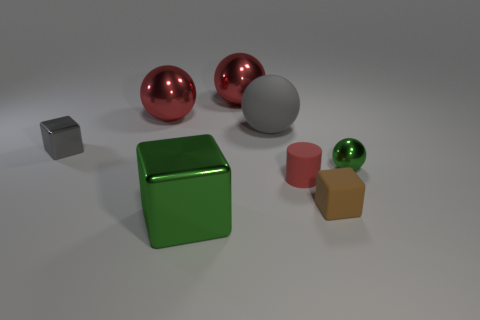Subtract all blocks. How many objects are left? 5 Subtract all matte spheres. How many spheres are left? 3 Add 2 small cyan metallic things. How many objects exist? 10 Subtract all green balls. How many balls are left? 3 Subtract 0 brown spheres. How many objects are left? 8 Subtract 2 cubes. How many cubes are left? 1 Subtract all green cylinders. Subtract all blue balls. How many cylinders are left? 1 Subtract all blue balls. How many red blocks are left? 0 Subtract all gray things. Subtract all blue matte objects. How many objects are left? 6 Add 7 big red shiny things. How many big red shiny things are left? 9 